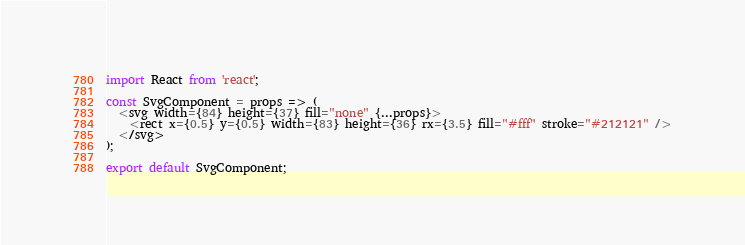Convert code to text. <code><loc_0><loc_0><loc_500><loc_500><_JavaScript_>import React from 'react';

const SvgComponent = props => (
  <svg width={84} height={37} fill="none" {...props}>
    <rect x={0.5} y={0.5} width={83} height={36} rx={3.5} fill="#fff" stroke="#212121" />
  </svg>
);

export default SvgComponent;
</code> 